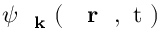Convert formula to latex. <formula><loc_0><loc_0><loc_500><loc_500>\psi _ { k } ( { r } , t )</formula> 